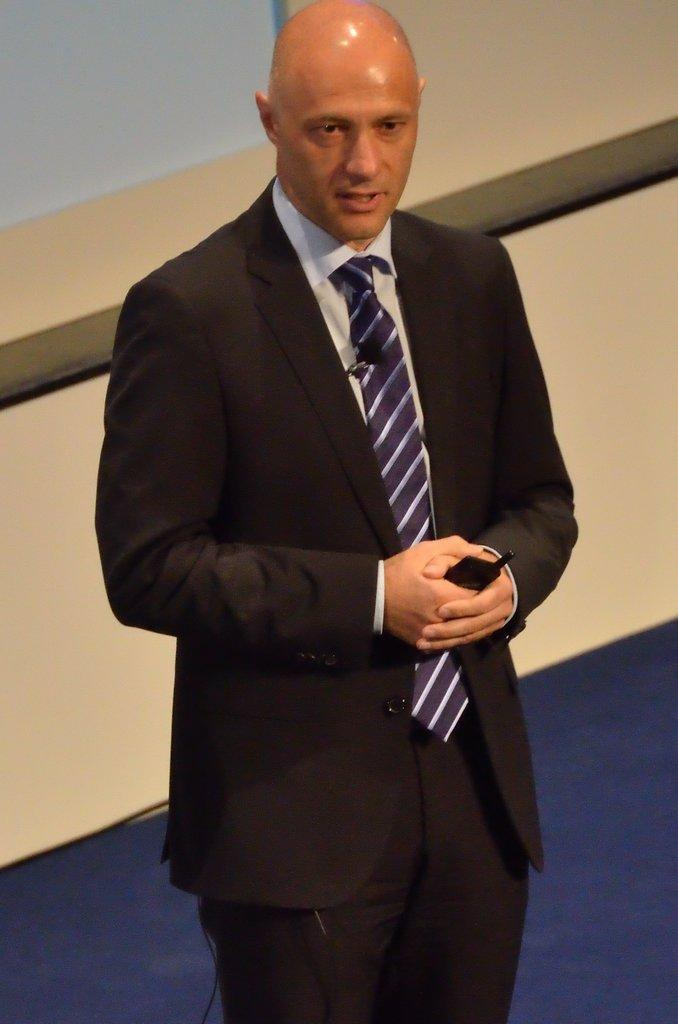What is the main subject of the image? There is a person standing in the image. What is the person holding in his hand? The person is holding a mobile in his hand. Can you describe the person's attire? The person is wearing a suit and tie. What can be seen in the background of the image? There is a wall visible in the background of the image. What type of journey is the person embarking on in the image? There is no indication of a journey in the image; it only shows a person standing with a mobile in his hand and wearing a suit and tie. 